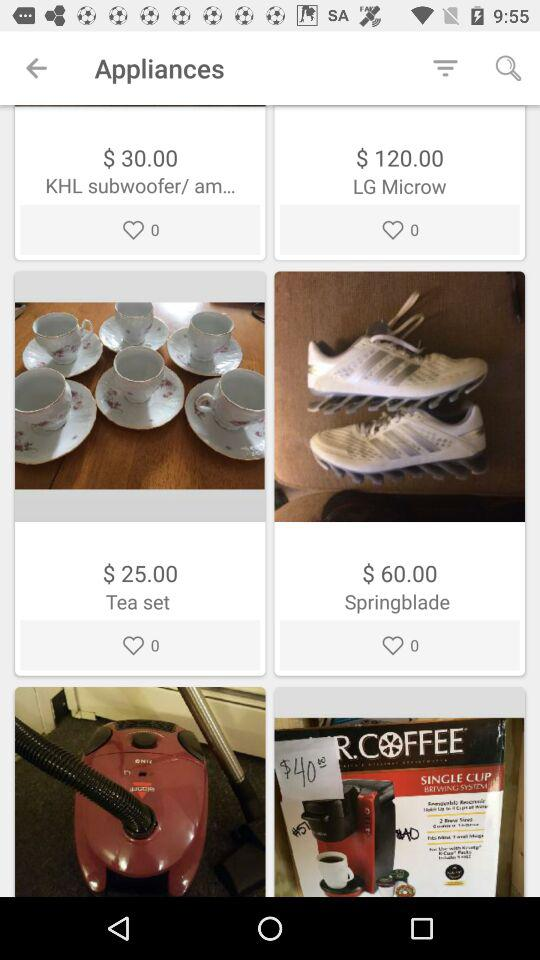What is the price of the tea set? The price of the tea set is $25.00. 